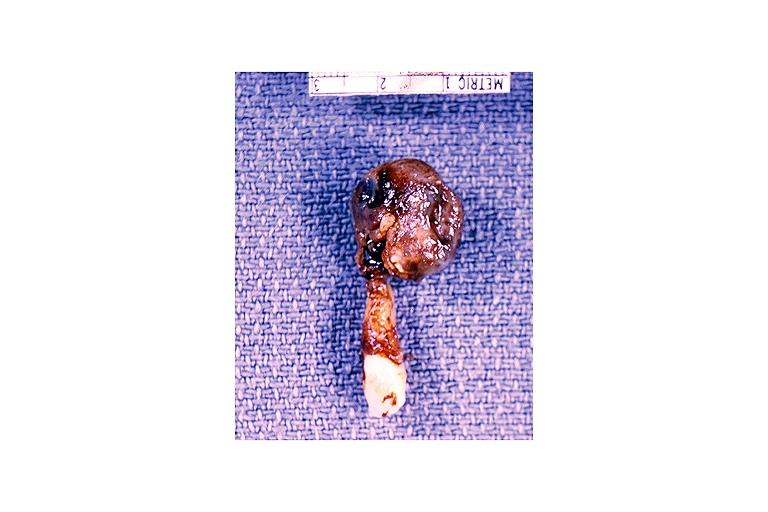what is present?
Answer the question using a single word or phrase. Oral 